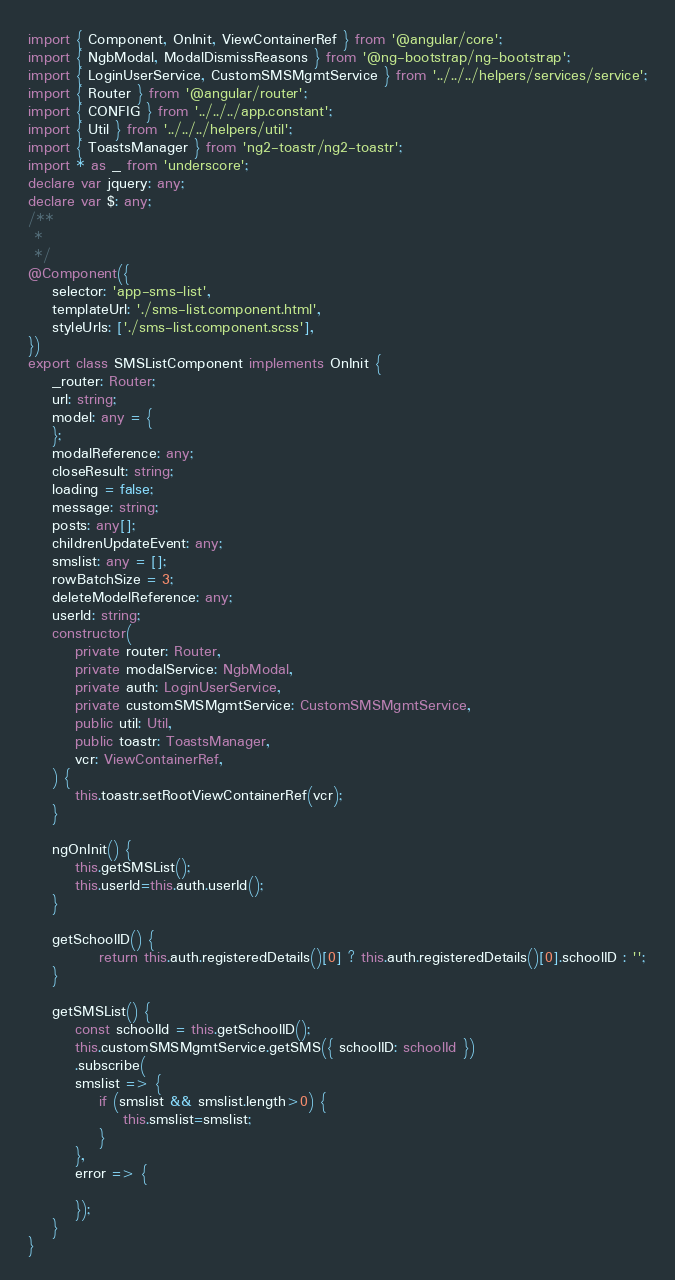Convert code to text. <code><loc_0><loc_0><loc_500><loc_500><_TypeScript_>import { Component, OnInit, ViewContainerRef } from '@angular/core';
import { NgbModal, ModalDismissReasons } from '@ng-bootstrap/ng-bootstrap';
import { LoginUserService, CustomSMSMgmtService } from '../../../helpers/services/service';
import { Router } from '@angular/router';
import { CONFIG } from '../../../app.constant';
import { Util } from '../../../helpers/util';
import { ToastsManager } from 'ng2-toastr/ng2-toastr';
import * as _ from 'underscore';
declare var jquery: any;
declare var $: any;
/**
 *
 */
@Component({
    selector: 'app-sms-list',
    templateUrl: './sms-list.component.html',
    styleUrls: ['./sms-list.component.scss'],
})
export class SMSListComponent implements OnInit {
    _router: Router;
    url: string;
    model: any = {
    };
    modalReference: any;
    closeResult: string;
    loading = false;
    message: string;
    posts: any[];
    childrenUpdateEvent: any;
    smslist: any = [];
    rowBatchSize = 3;
    deleteModelReference: any;
    userId: string;
    constructor(
        private router: Router,
        private modalService: NgbModal,
        private auth: LoginUserService,
        private customSMSMgmtService: CustomSMSMgmtService,
        public util: Util,
        public toastr: ToastsManager,
        vcr: ViewContainerRef,
    ) {
        this.toastr.setRootViewContainerRef(vcr);
    }

    ngOnInit() {
        this.getSMSList();
        this.userId=this.auth.userId();
    }

    getSchoolID() {
            return this.auth.registeredDetails()[0] ? this.auth.registeredDetails()[0].schoolID : '';
    }

    getSMSList() {
        const schoolId = this.getSchoolID();
        this.customSMSMgmtService.getSMS({ schoolID: schoolId })
        .subscribe(
        smslist => {
            if (smslist && smslist.length>0) {
                this.smslist=smslist;
            }
        },
        error => {
            
        });
    }
}



</code> 